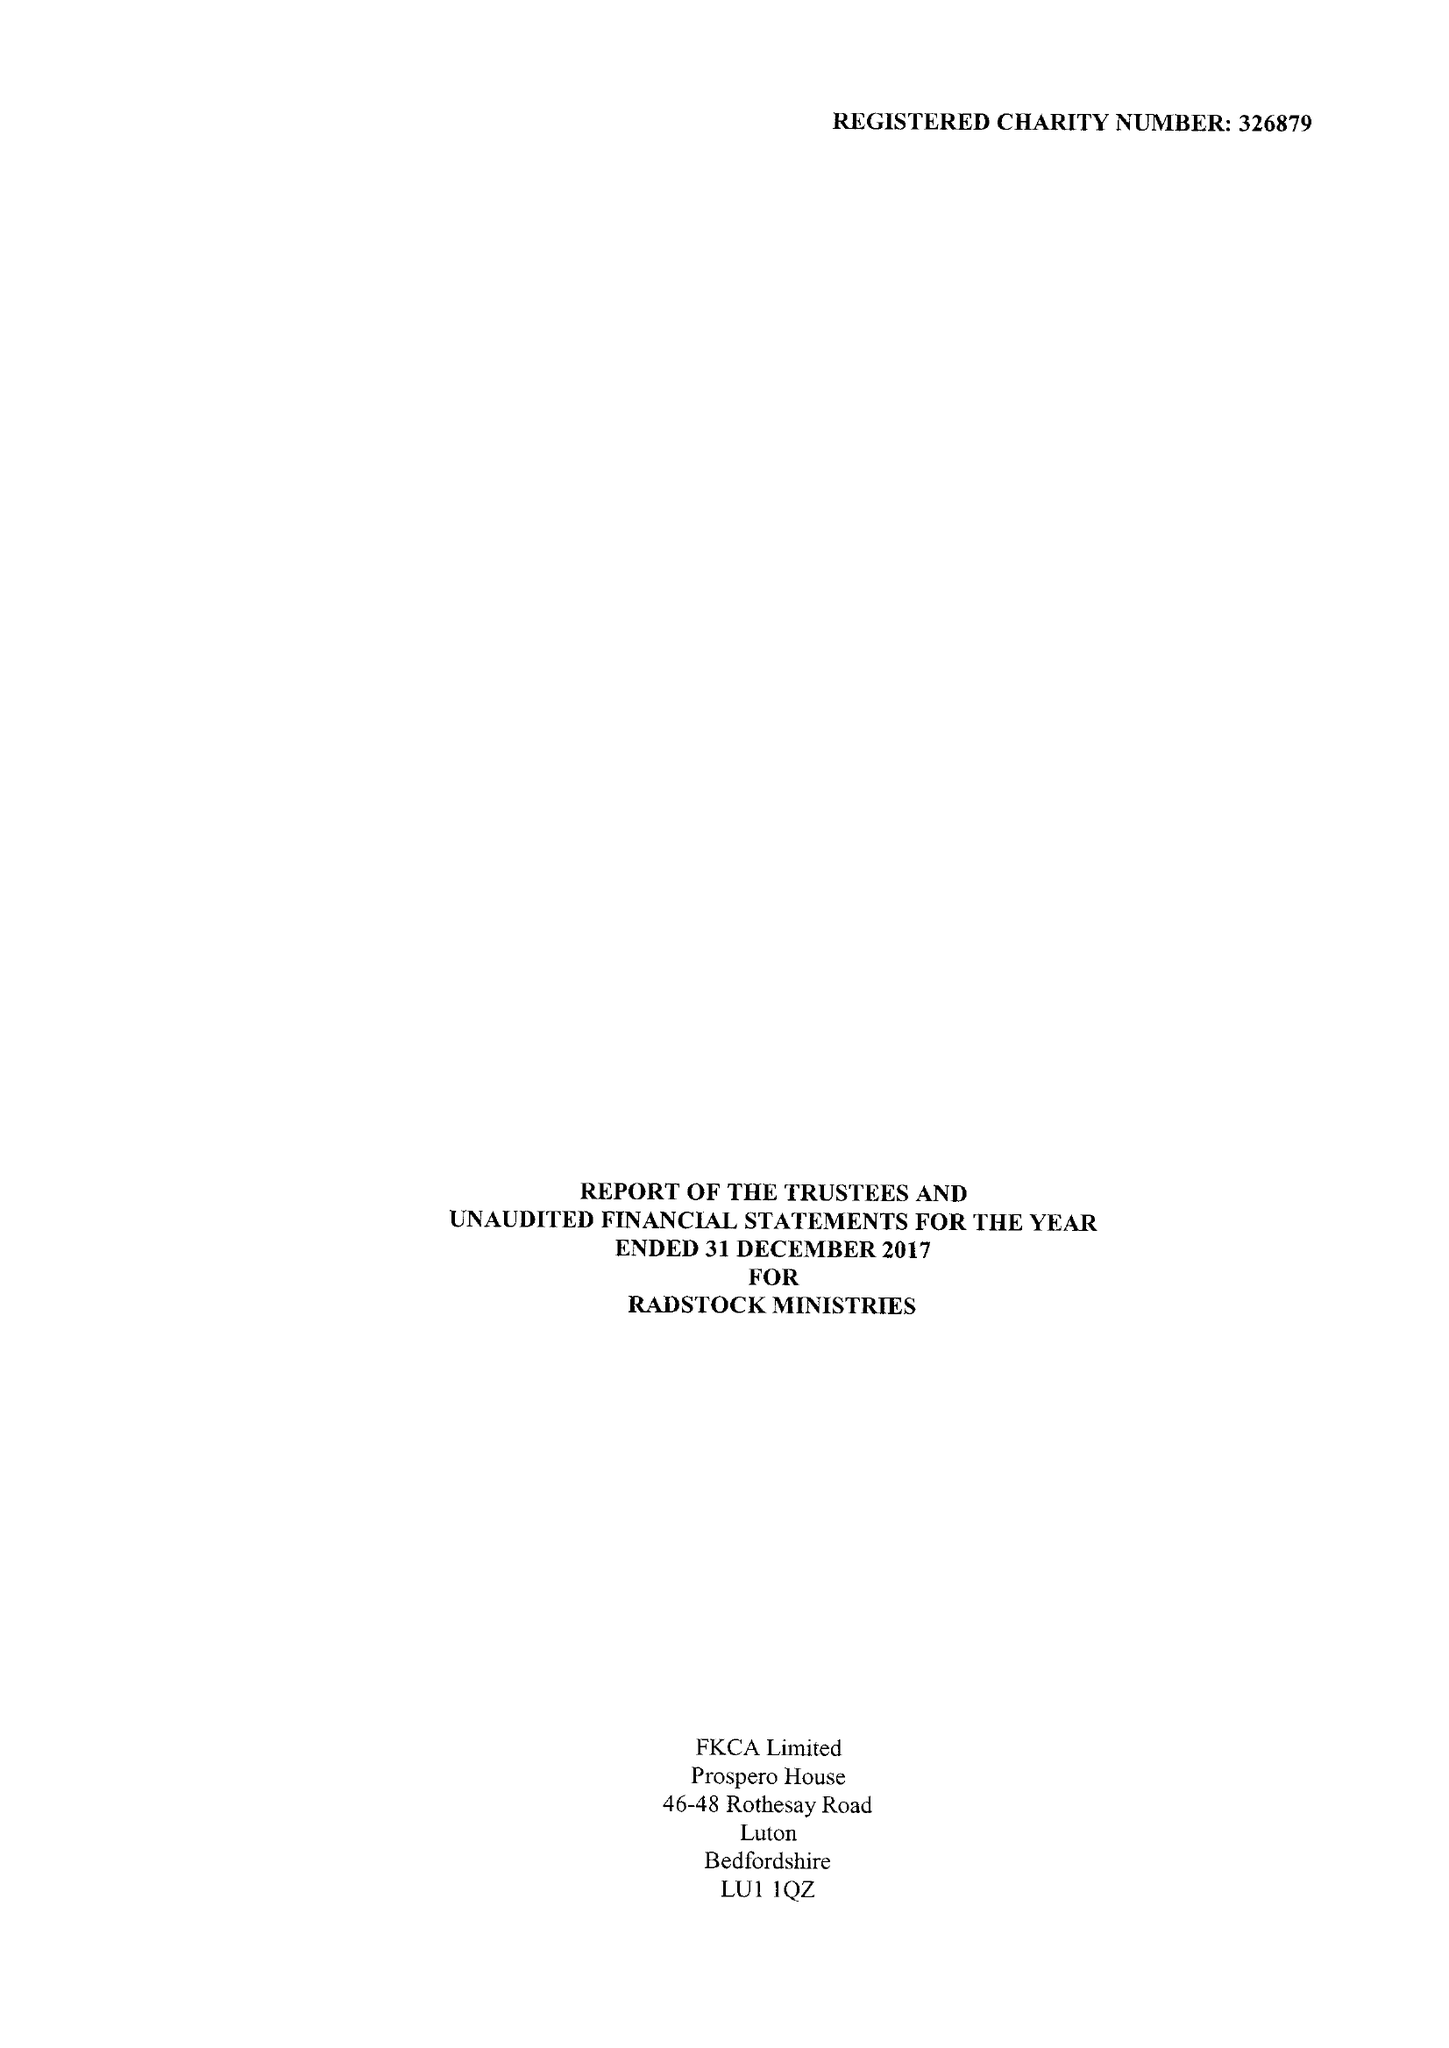What is the value for the income_annually_in_british_pounds?
Answer the question using a single word or phrase. 192849.00 